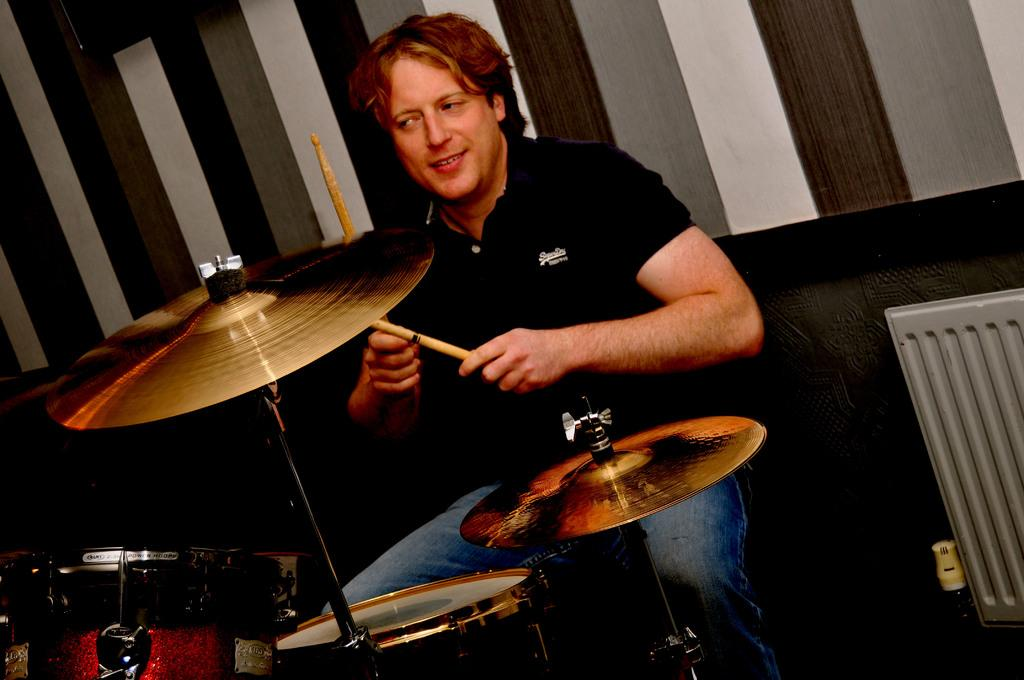What is the main subject in the foreground of the image? There is a man in the foreground of the image. What is the man doing in the image? The man is sitting behind the drums. What is the man holding in his hand? The man is holding drum sticks in his hand. What can be seen in the background of the image? There is a wall in the background of the image. What type of impulse can be seen affecting the man's drumming in the image? There is no indication of any impulse affecting the man's drumming in the image. 